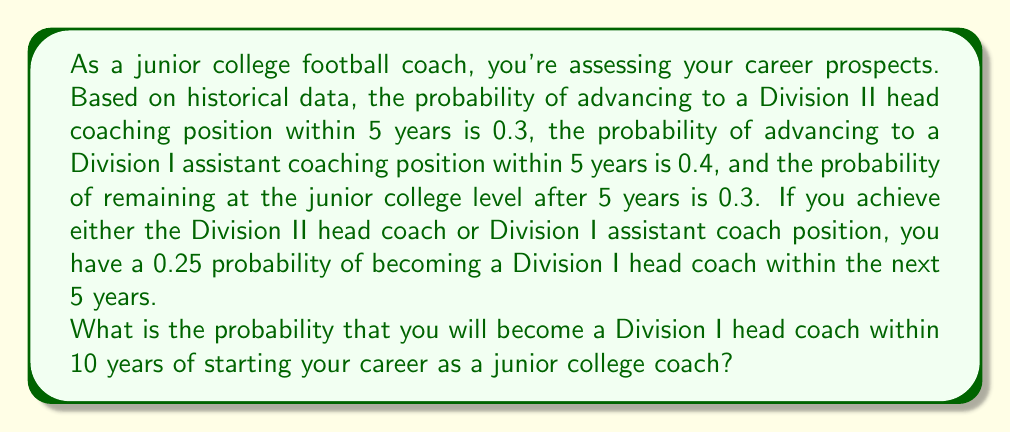Could you help me with this problem? Let's approach this step-by-step using the law of total probability:

1) First, we need to calculate the probability of reaching either a Division II head coach or Division I assistant coach position within the first 5 years:

   $P(\text{Div II head or Div I assistant}) = 0.3 + 0.4 = 0.7$

2) Now, we can calculate the probability of becoming a Division I head coach within 10 years. This can happen in two ways:
   a) Advancing to Div II head or Div I assistant in the first 5 years, then becoming a Div I head coach in the next 5 years
   b) Remaining at junior college level for the first 5 years (thus not becoming a Div I head coach)

3) Let's calculate the probability of scenario (a):

   $P(\text{a}) = P(\text{Div II head or Div I assistant}) \times P(\text{Div I head | Div II head or Div I assistant})$
   $P(\text{a}) = 0.7 \times 0.25 = 0.175$

4) The probability of scenario (b) is 0, as remaining at junior college level for 5 years doesn't lead to becoming a Div I head coach within 10 years in this model.

5) Therefore, the total probability is just the probability of scenario (a):

   $P(\text{Div I head within 10 years}) = P(\text{a}) = 0.175$
Answer: The probability of becoming a Division I head coach within 10 years of starting as a junior college coach is 0.175 or 17.5%. 